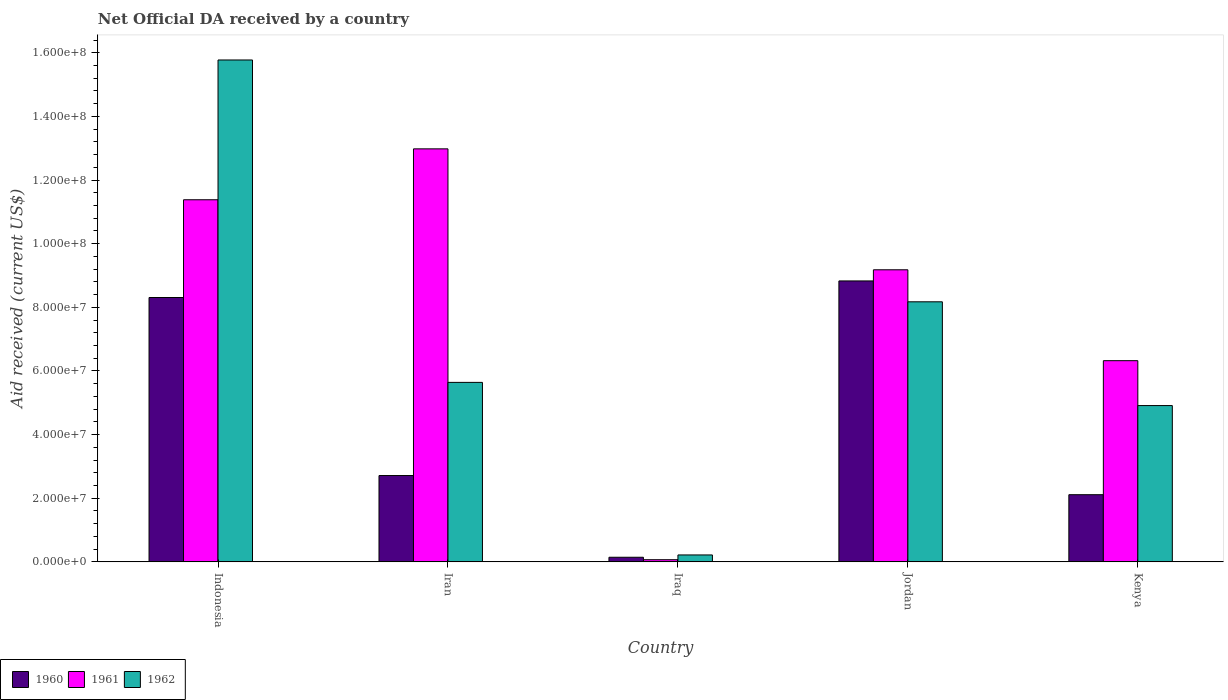How many different coloured bars are there?
Ensure brevity in your answer.  3. How many groups of bars are there?
Your response must be concise. 5. Are the number of bars per tick equal to the number of legend labels?
Keep it short and to the point. Yes. Are the number of bars on each tick of the X-axis equal?
Offer a very short reply. Yes. How many bars are there on the 3rd tick from the left?
Offer a very short reply. 3. What is the label of the 4th group of bars from the left?
Provide a succinct answer. Jordan. In how many cases, is the number of bars for a given country not equal to the number of legend labels?
Offer a terse response. 0. What is the net official development assistance aid received in 1961 in Iraq?
Ensure brevity in your answer.  6.80e+05. Across all countries, what is the maximum net official development assistance aid received in 1962?
Your answer should be very brief. 1.58e+08. Across all countries, what is the minimum net official development assistance aid received in 1961?
Your answer should be very brief. 6.80e+05. In which country was the net official development assistance aid received in 1960 maximum?
Keep it short and to the point. Jordan. In which country was the net official development assistance aid received in 1961 minimum?
Give a very brief answer. Iraq. What is the total net official development assistance aid received in 1960 in the graph?
Give a very brief answer. 2.21e+08. What is the difference between the net official development assistance aid received in 1961 in Iraq and that in Jordan?
Your answer should be compact. -9.11e+07. What is the difference between the net official development assistance aid received in 1961 in Iran and the net official development assistance aid received in 1960 in Iraq?
Ensure brevity in your answer.  1.28e+08. What is the average net official development assistance aid received in 1960 per country?
Make the answer very short. 4.42e+07. What is the difference between the net official development assistance aid received of/in 1961 and net official development assistance aid received of/in 1962 in Iraq?
Your answer should be compact. -1.50e+06. In how many countries, is the net official development assistance aid received in 1961 greater than 20000000 US$?
Your response must be concise. 4. What is the ratio of the net official development assistance aid received in 1961 in Indonesia to that in Jordan?
Provide a short and direct response. 1.24. Is the net official development assistance aid received in 1962 in Indonesia less than that in Jordan?
Give a very brief answer. No. Is the difference between the net official development assistance aid received in 1961 in Indonesia and Iraq greater than the difference between the net official development assistance aid received in 1962 in Indonesia and Iraq?
Your answer should be very brief. No. What is the difference between the highest and the second highest net official development assistance aid received in 1961?
Give a very brief answer. 1.60e+07. What is the difference between the highest and the lowest net official development assistance aid received in 1962?
Your answer should be very brief. 1.56e+08. In how many countries, is the net official development assistance aid received in 1961 greater than the average net official development assistance aid received in 1961 taken over all countries?
Provide a short and direct response. 3. Is the sum of the net official development assistance aid received in 1961 in Indonesia and Iran greater than the maximum net official development assistance aid received in 1962 across all countries?
Offer a very short reply. Yes. Is it the case that in every country, the sum of the net official development assistance aid received in 1960 and net official development assistance aid received in 1961 is greater than the net official development assistance aid received in 1962?
Give a very brief answer. No. How many bars are there?
Make the answer very short. 15. Are all the bars in the graph horizontal?
Your answer should be compact. No. How many countries are there in the graph?
Provide a short and direct response. 5. What is the difference between two consecutive major ticks on the Y-axis?
Your answer should be compact. 2.00e+07. How many legend labels are there?
Make the answer very short. 3. What is the title of the graph?
Ensure brevity in your answer.  Net Official DA received by a country. What is the label or title of the X-axis?
Your answer should be very brief. Country. What is the label or title of the Y-axis?
Provide a short and direct response. Aid received (current US$). What is the Aid received (current US$) of 1960 in Indonesia?
Offer a terse response. 8.31e+07. What is the Aid received (current US$) of 1961 in Indonesia?
Your response must be concise. 1.14e+08. What is the Aid received (current US$) in 1962 in Indonesia?
Offer a terse response. 1.58e+08. What is the Aid received (current US$) in 1960 in Iran?
Provide a succinct answer. 2.71e+07. What is the Aid received (current US$) of 1961 in Iran?
Your answer should be compact. 1.30e+08. What is the Aid received (current US$) of 1962 in Iran?
Give a very brief answer. 5.64e+07. What is the Aid received (current US$) in 1960 in Iraq?
Provide a succinct answer. 1.45e+06. What is the Aid received (current US$) of 1961 in Iraq?
Your response must be concise. 6.80e+05. What is the Aid received (current US$) in 1962 in Iraq?
Provide a short and direct response. 2.18e+06. What is the Aid received (current US$) of 1960 in Jordan?
Your response must be concise. 8.83e+07. What is the Aid received (current US$) in 1961 in Jordan?
Make the answer very short. 9.18e+07. What is the Aid received (current US$) in 1962 in Jordan?
Ensure brevity in your answer.  8.17e+07. What is the Aid received (current US$) in 1960 in Kenya?
Your answer should be very brief. 2.11e+07. What is the Aid received (current US$) of 1961 in Kenya?
Provide a short and direct response. 6.32e+07. What is the Aid received (current US$) in 1962 in Kenya?
Offer a very short reply. 4.91e+07. Across all countries, what is the maximum Aid received (current US$) in 1960?
Provide a succinct answer. 8.83e+07. Across all countries, what is the maximum Aid received (current US$) of 1961?
Provide a short and direct response. 1.30e+08. Across all countries, what is the maximum Aid received (current US$) of 1962?
Make the answer very short. 1.58e+08. Across all countries, what is the minimum Aid received (current US$) of 1960?
Ensure brevity in your answer.  1.45e+06. Across all countries, what is the minimum Aid received (current US$) of 1961?
Provide a succinct answer. 6.80e+05. Across all countries, what is the minimum Aid received (current US$) in 1962?
Offer a terse response. 2.18e+06. What is the total Aid received (current US$) in 1960 in the graph?
Your answer should be compact. 2.21e+08. What is the total Aid received (current US$) of 1961 in the graph?
Provide a succinct answer. 3.99e+08. What is the total Aid received (current US$) of 1962 in the graph?
Your answer should be compact. 3.47e+08. What is the difference between the Aid received (current US$) of 1960 in Indonesia and that in Iran?
Your answer should be very brief. 5.60e+07. What is the difference between the Aid received (current US$) of 1961 in Indonesia and that in Iran?
Offer a terse response. -1.60e+07. What is the difference between the Aid received (current US$) of 1962 in Indonesia and that in Iran?
Give a very brief answer. 1.01e+08. What is the difference between the Aid received (current US$) of 1960 in Indonesia and that in Iraq?
Offer a terse response. 8.16e+07. What is the difference between the Aid received (current US$) in 1961 in Indonesia and that in Iraq?
Make the answer very short. 1.13e+08. What is the difference between the Aid received (current US$) of 1962 in Indonesia and that in Iraq?
Your response must be concise. 1.56e+08. What is the difference between the Aid received (current US$) of 1960 in Indonesia and that in Jordan?
Make the answer very short. -5.21e+06. What is the difference between the Aid received (current US$) in 1961 in Indonesia and that in Jordan?
Your response must be concise. 2.20e+07. What is the difference between the Aid received (current US$) of 1962 in Indonesia and that in Jordan?
Provide a succinct answer. 7.60e+07. What is the difference between the Aid received (current US$) in 1960 in Indonesia and that in Kenya?
Provide a succinct answer. 6.20e+07. What is the difference between the Aid received (current US$) in 1961 in Indonesia and that in Kenya?
Provide a succinct answer. 5.06e+07. What is the difference between the Aid received (current US$) in 1962 in Indonesia and that in Kenya?
Give a very brief answer. 1.09e+08. What is the difference between the Aid received (current US$) in 1960 in Iran and that in Iraq?
Provide a short and direct response. 2.57e+07. What is the difference between the Aid received (current US$) of 1961 in Iran and that in Iraq?
Your answer should be very brief. 1.29e+08. What is the difference between the Aid received (current US$) of 1962 in Iran and that in Iraq?
Provide a succinct answer. 5.42e+07. What is the difference between the Aid received (current US$) in 1960 in Iran and that in Jordan?
Your answer should be very brief. -6.12e+07. What is the difference between the Aid received (current US$) in 1961 in Iran and that in Jordan?
Your answer should be very brief. 3.80e+07. What is the difference between the Aid received (current US$) in 1962 in Iran and that in Jordan?
Your answer should be compact. -2.53e+07. What is the difference between the Aid received (current US$) in 1960 in Iran and that in Kenya?
Your response must be concise. 6.02e+06. What is the difference between the Aid received (current US$) of 1961 in Iran and that in Kenya?
Provide a succinct answer. 6.66e+07. What is the difference between the Aid received (current US$) in 1962 in Iran and that in Kenya?
Offer a terse response. 7.29e+06. What is the difference between the Aid received (current US$) of 1960 in Iraq and that in Jordan?
Give a very brief answer. -8.68e+07. What is the difference between the Aid received (current US$) of 1961 in Iraq and that in Jordan?
Your answer should be very brief. -9.11e+07. What is the difference between the Aid received (current US$) in 1962 in Iraq and that in Jordan?
Provide a succinct answer. -7.96e+07. What is the difference between the Aid received (current US$) of 1960 in Iraq and that in Kenya?
Your answer should be compact. -1.97e+07. What is the difference between the Aid received (current US$) in 1961 in Iraq and that in Kenya?
Keep it short and to the point. -6.26e+07. What is the difference between the Aid received (current US$) in 1962 in Iraq and that in Kenya?
Ensure brevity in your answer.  -4.69e+07. What is the difference between the Aid received (current US$) in 1960 in Jordan and that in Kenya?
Ensure brevity in your answer.  6.72e+07. What is the difference between the Aid received (current US$) in 1961 in Jordan and that in Kenya?
Your answer should be very brief. 2.86e+07. What is the difference between the Aid received (current US$) in 1962 in Jordan and that in Kenya?
Offer a terse response. 3.26e+07. What is the difference between the Aid received (current US$) of 1960 in Indonesia and the Aid received (current US$) of 1961 in Iran?
Your response must be concise. -4.67e+07. What is the difference between the Aid received (current US$) in 1960 in Indonesia and the Aid received (current US$) in 1962 in Iran?
Give a very brief answer. 2.67e+07. What is the difference between the Aid received (current US$) of 1961 in Indonesia and the Aid received (current US$) of 1962 in Iran?
Your answer should be very brief. 5.74e+07. What is the difference between the Aid received (current US$) of 1960 in Indonesia and the Aid received (current US$) of 1961 in Iraq?
Offer a terse response. 8.24e+07. What is the difference between the Aid received (current US$) in 1960 in Indonesia and the Aid received (current US$) in 1962 in Iraq?
Provide a short and direct response. 8.09e+07. What is the difference between the Aid received (current US$) of 1961 in Indonesia and the Aid received (current US$) of 1962 in Iraq?
Provide a succinct answer. 1.12e+08. What is the difference between the Aid received (current US$) of 1960 in Indonesia and the Aid received (current US$) of 1961 in Jordan?
Offer a very short reply. -8.71e+06. What is the difference between the Aid received (current US$) of 1960 in Indonesia and the Aid received (current US$) of 1962 in Jordan?
Keep it short and to the point. 1.35e+06. What is the difference between the Aid received (current US$) of 1961 in Indonesia and the Aid received (current US$) of 1962 in Jordan?
Your answer should be very brief. 3.21e+07. What is the difference between the Aid received (current US$) of 1960 in Indonesia and the Aid received (current US$) of 1961 in Kenya?
Provide a succinct answer. 1.98e+07. What is the difference between the Aid received (current US$) in 1960 in Indonesia and the Aid received (current US$) in 1962 in Kenya?
Keep it short and to the point. 3.40e+07. What is the difference between the Aid received (current US$) in 1961 in Indonesia and the Aid received (current US$) in 1962 in Kenya?
Your answer should be very brief. 6.47e+07. What is the difference between the Aid received (current US$) in 1960 in Iran and the Aid received (current US$) in 1961 in Iraq?
Keep it short and to the point. 2.64e+07. What is the difference between the Aid received (current US$) of 1960 in Iran and the Aid received (current US$) of 1962 in Iraq?
Offer a terse response. 2.50e+07. What is the difference between the Aid received (current US$) in 1961 in Iran and the Aid received (current US$) in 1962 in Iraq?
Give a very brief answer. 1.28e+08. What is the difference between the Aid received (current US$) in 1960 in Iran and the Aid received (current US$) in 1961 in Jordan?
Ensure brevity in your answer.  -6.47e+07. What is the difference between the Aid received (current US$) in 1960 in Iran and the Aid received (current US$) in 1962 in Jordan?
Offer a terse response. -5.46e+07. What is the difference between the Aid received (current US$) of 1961 in Iran and the Aid received (current US$) of 1962 in Jordan?
Ensure brevity in your answer.  4.81e+07. What is the difference between the Aid received (current US$) of 1960 in Iran and the Aid received (current US$) of 1961 in Kenya?
Your answer should be compact. -3.61e+07. What is the difference between the Aid received (current US$) of 1960 in Iran and the Aid received (current US$) of 1962 in Kenya?
Offer a terse response. -2.20e+07. What is the difference between the Aid received (current US$) of 1961 in Iran and the Aid received (current US$) of 1962 in Kenya?
Provide a short and direct response. 8.07e+07. What is the difference between the Aid received (current US$) in 1960 in Iraq and the Aid received (current US$) in 1961 in Jordan?
Make the answer very short. -9.03e+07. What is the difference between the Aid received (current US$) in 1960 in Iraq and the Aid received (current US$) in 1962 in Jordan?
Give a very brief answer. -8.03e+07. What is the difference between the Aid received (current US$) in 1961 in Iraq and the Aid received (current US$) in 1962 in Jordan?
Offer a terse response. -8.10e+07. What is the difference between the Aid received (current US$) in 1960 in Iraq and the Aid received (current US$) in 1961 in Kenya?
Make the answer very short. -6.18e+07. What is the difference between the Aid received (current US$) in 1960 in Iraq and the Aid received (current US$) in 1962 in Kenya?
Provide a short and direct response. -4.77e+07. What is the difference between the Aid received (current US$) of 1961 in Iraq and the Aid received (current US$) of 1962 in Kenya?
Your answer should be compact. -4.84e+07. What is the difference between the Aid received (current US$) in 1960 in Jordan and the Aid received (current US$) in 1961 in Kenya?
Your answer should be compact. 2.51e+07. What is the difference between the Aid received (current US$) of 1960 in Jordan and the Aid received (current US$) of 1962 in Kenya?
Ensure brevity in your answer.  3.92e+07. What is the difference between the Aid received (current US$) of 1961 in Jordan and the Aid received (current US$) of 1962 in Kenya?
Provide a short and direct response. 4.27e+07. What is the average Aid received (current US$) in 1960 per country?
Provide a short and direct response. 4.42e+07. What is the average Aid received (current US$) of 1961 per country?
Give a very brief answer. 7.99e+07. What is the average Aid received (current US$) in 1962 per country?
Offer a terse response. 6.94e+07. What is the difference between the Aid received (current US$) in 1960 and Aid received (current US$) in 1961 in Indonesia?
Keep it short and to the point. -3.07e+07. What is the difference between the Aid received (current US$) in 1960 and Aid received (current US$) in 1962 in Indonesia?
Offer a very short reply. -7.46e+07. What is the difference between the Aid received (current US$) in 1961 and Aid received (current US$) in 1962 in Indonesia?
Your response must be concise. -4.39e+07. What is the difference between the Aid received (current US$) of 1960 and Aid received (current US$) of 1961 in Iran?
Keep it short and to the point. -1.03e+08. What is the difference between the Aid received (current US$) of 1960 and Aid received (current US$) of 1962 in Iran?
Keep it short and to the point. -2.93e+07. What is the difference between the Aid received (current US$) in 1961 and Aid received (current US$) in 1962 in Iran?
Offer a very short reply. 7.34e+07. What is the difference between the Aid received (current US$) in 1960 and Aid received (current US$) in 1961 in Iraq?
Ensure brevity in your answer.  7.70e+05. What is the difference between the Aid received (current US$) in 1960 and Aid received (current US$) in 1962 in Iraq?
Keep it short and to the point. -7.30e+05. What is the difference between the Aid received (current US$) in 1961 and Aid received (current US$) in 1962 in Iraq?
Your answer should be compact. -1.50e+06. What is the difference between the Aid received (current US$) of 1960 and Aid received (current US$) of 1961 in Jordan?
Ensure brevity in your answer.  -3.50e+06. What is the difference between the Aid received (current US$) in 1960 and Aid received (current US$) in 1962 in Jordan?
Provide a succinct answer. 6.56e+06. What is the difference between the Aid received (current US$) of 1961 and Aid received (current US$) of 1962 in Jordan?
Your answer should be very brief. 1.01e+07. What is the difference between the Aid received (current US$) of 1960 and Aid received (current US$) of 1961 in Kenya?
Offer a terse response. -4.21e+07. What is the difference between the Aid received (current US$) of 1960 and Aid received (current US$) of 1962 in Kenya?
Offer a very short reply. -2.80e+07. What is the difference between the Aid received (current US$) in 1961 and Aid received (current US$) in 1962 in Kenya?
Provide a succinct answer. 1.41e+07. What is the ratio of the Aid received (current US$) in 1960 in Indonesia to that in Iran?
Your answer should be very brief. 3.06. What is the ratio of the Aid received (current US$) of 1961 in Indonesia to that in Iran?
Provide a short and direct response. 0.88. What is the ratio of the Aid received (current US$) in 1962 in Indonesia to that in Iran?
Provide a short and direct response. 2.8. What is the ratio of the Aid received (current US$) of 1960 in Indonesia to that in Iraq?
Keep it short and to the point. 57.3. What is the ratio of the Aid received (current US$) in 1961 in Indonesia to that in Iraq?
Your answer should be compact. 167.35. What is the ratio of the Aid received (current US$) of 1962 in Indonesia to that in Iraq?
Your answer should be compact. 72.35. What is the ratio of the Aid received (current US$) in 1960 in Indonesia to that in Jordan?
Make the answer very short. 0.94. What is the ratio of the Aid received (current US$) of 1961 in Indonesia to that in Jordan?
Offer a terse response. 1.24. What is the ratio of the Aid received (current US$) in 1962 in Indonesia to that in Jordan?
Ensure brevity in your answer.  1.93. What is the ratio of the Aid received (current US$) of 1960 in Indonesia to that in Kenya?
Your response must be concise. 3.94. What is the ratio of the Aid received (current US$) in 1961 in Indonesia to that in Kenya?
Your answer should be compact. 1.8. What is the ratio of the Aid received (current US$) in 1962 in Indonesia to that in Kenya?
Your response must be concise. 3.21. What is the ratio of the Aid received (current US$) of 1960 in Iran to that in Iraq?
Your response must be concise. 18.71. What is the ratio of the Aid received (current US$) of 1961 in Iran to that in Iraq?
Make the answer very short. 190.88. What is the ratio of the Aid received (current US$) in 1962 in Iran to that in Iraq?
Give a very brief answer. 25.88. What is the ratio of the Aid received (current US$) of 1960 in Iran to that in Jordan?
Provide a short and direct response. 0.31. What is the ratio of the Aid received (current US$) of 1961 in Iran to that in Jordan?
Provide a succinct answer. 1.41. What is the ratio of the Aid received (current US$) in 1962 in Iran to that in Jordan?
Offer a very short reply. 0.69. What is the ratio of the Aid received (current US$) of 1960 in Iran to that in Kenya?
Your answer should be very brief. 1.29. What is the ratio of the Aid received (current US$) in 1961 in Iran to that in Kenya?
Make the answer very short. 2.05. What is the ratio of the Aid received (current US$) in 1962 in Iran to that in Kenya?
Make the answer very short. 1.15. What is the ratio of the Aid received (current US$) in 1960 in Iraq to that in Jordan?
Keep it short and to the point. 0.02. What is the ratio of the Aid received (current US$) in 1961 in Iraq to that in Jordan?
Your response must be concise. 0.01. What is the ratio of the Aid received (current US$) of 1962 in Iraq to that in Jordan?
Ensure brevity in your answer.  0.03. What is the ratio of the Aid received (current US$) in 1960 in Iraq to that in Kenya?
Ensure brevity in your answer.  0.07. What is the ratio of the Aid received (current US$) in 1961 in Iraq to that in Kenya?
Your answer should be very brief. 0.01. What is the ratio of the Aid received (current US$) in 1962 in Iraq to that in Kenya?
Your answer should be very brief. 0.04. What is the ratio of the Aid received (current US$) of 1960 in Jordan to that in Kenya?
Give a very brief answer. 4.18. What is the ratio of the Aid received (current US$) in 1961 in Jordan to that in Kenya?
Your response must be concise. 1.45. What is the ratio of the Aid received (current US$) of 1962 in Jordan to that in Kenya?
Keep it short and to the point. 1.66. What is the difference between the highest and the second highest Aid received (current US$) of 1960?
Make the answer very short. 5.21e+06. What is the difference between the highest and the second highest Aid received (current US$) of 1961?
Your answer should be compact. 1.60e+07. What is the difference between the highest and the second highest Aid received (current US$) in 1962?
Your answer should be compact. 7.60e+07. What is the difference between the highest and the lowest Aid received (current US$) of 1960?
Give a very brief answer. 8.68e+07. What is the difference between the highest and the lowest Aid received (current US$) in 1961?
Your response must be concise. 1.29e+08. What is the difference between the highest and the lowest Aid received (current US$) of 1962?
Your response must be concise. 1.56e+08. 